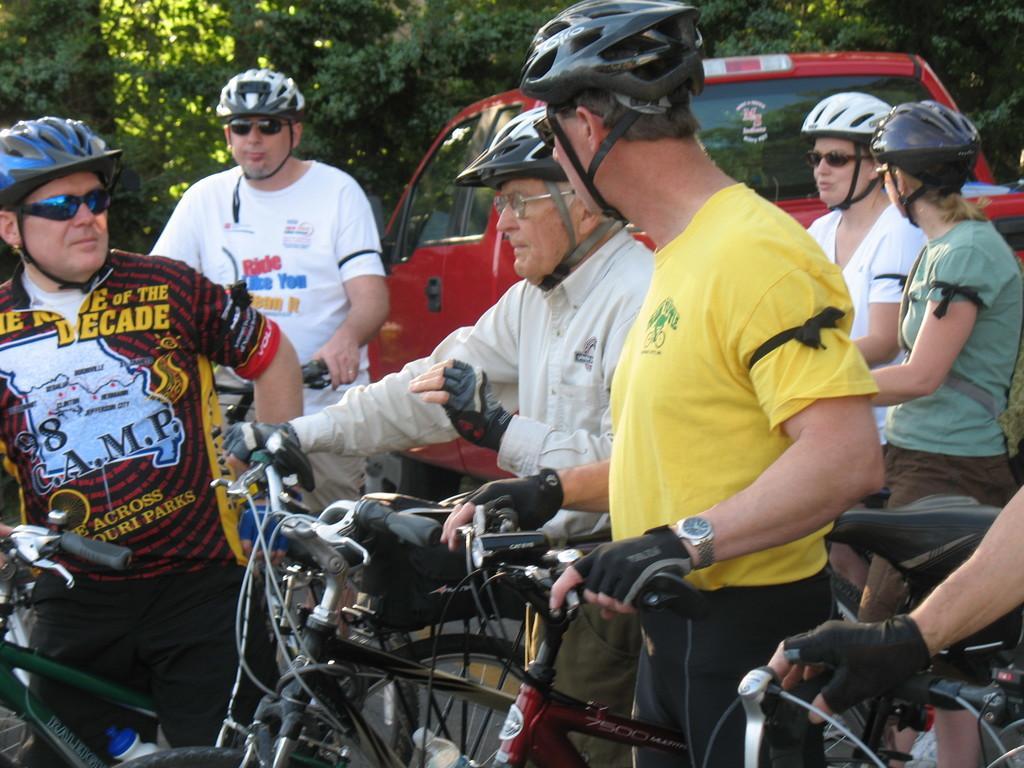In one or two sentences, can you explain what this image depicts? in this image the many persons they are standing on the bicycle and one is he is sitting on the bike he is wearing the white shirt and whoever they are sitting on the bicycle they are wearing t- shirt and the other side the car is parking and the background is very greenery. 